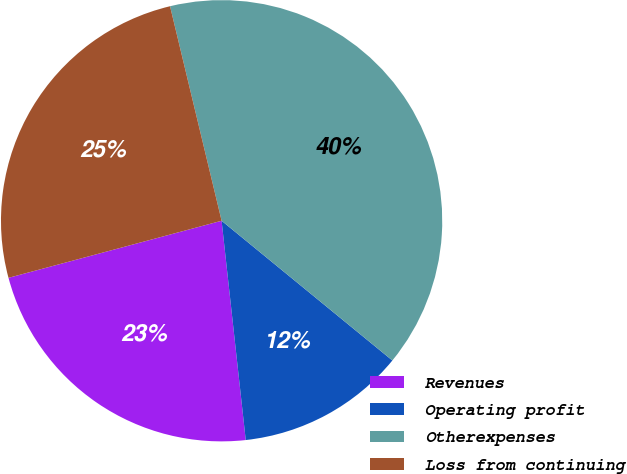Convert chart to OTSL. <chart><loc_0><loc_0><loc_500><loc_500><pie_chart><fcel>Revenues<fcel>Operating profit<fcel>Otherexpenses<fcel>Loss from continuing<nl><fcel>22.58%<fcel>12.34%<fcel>39.67%<fcel>25.41%<nl></chart> 